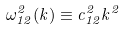Convert formula to latex. <formula><loc_0><loc_0><loc_500><loc_500>\omega _ { 1 2 } ^ { 2 } ( k ) \equiv c _ { 1 2 } ^ { 2 } k ^ { 2 }</formula> 